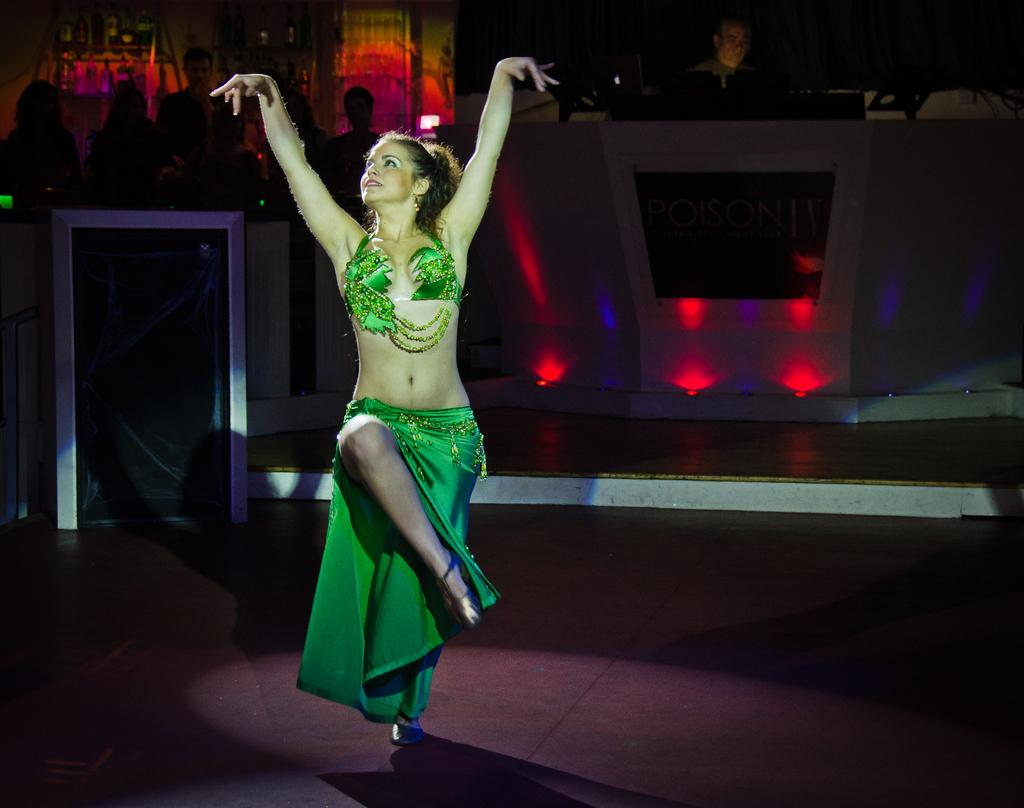What is the woman in the image doing? The woman is dancing in the image. Where is the woman located in the image? The woman is on the floor in the image. What can be seen in the image besides the woman? There are lights, a board, and people visible in the image. What is present in the background of the image? There are bottles on racks in the background of the image. How many dimes are scattered on the floor near the woman? There are no dimes visible in the image; the woman is dancing on the floor. 